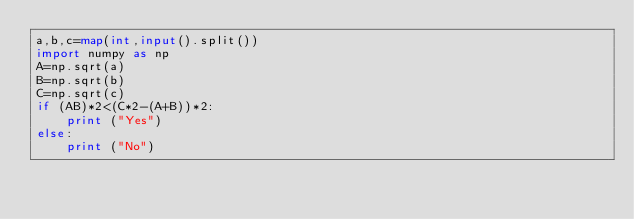Convert code to text. <code><loc_0><loc_0><loc_500><loc_500><_Python_>a,b,c=map(int,input().split())
import numpy as np
A=np.sqrt(a)
B=np.sqrt(b)
C=np.sqrt(c)
if (AB)*2<(C*2-(A+B))*2:
    print ("Yes")
else:
    print ("No")
    </code> 